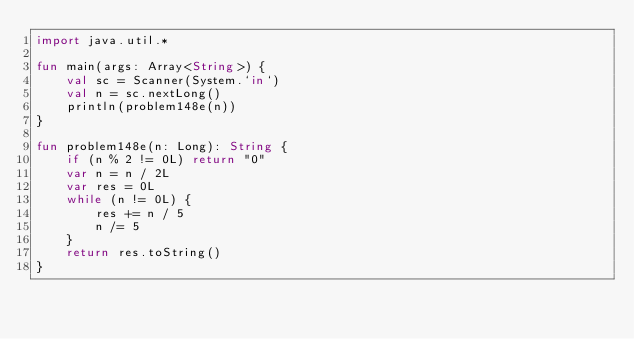Convert code to text. <code><loc_0><loc_0><loc_500><loc_500><_Kotlin_>import java.util.*

fun main(args: Array<String>) {
    val sc = Scanner(System.`in`)
    val n = sc.nextLong()
    println(problem148e(n))
}

fun problem148e(n: Long): String {
    if (n % 2 != 0L) return "0"
    var n = n / 2L
    var res = 0L
    while (n != 0L) {
        res += n / 5
        n /= 5
    }
    return res.toString()
}</code> 